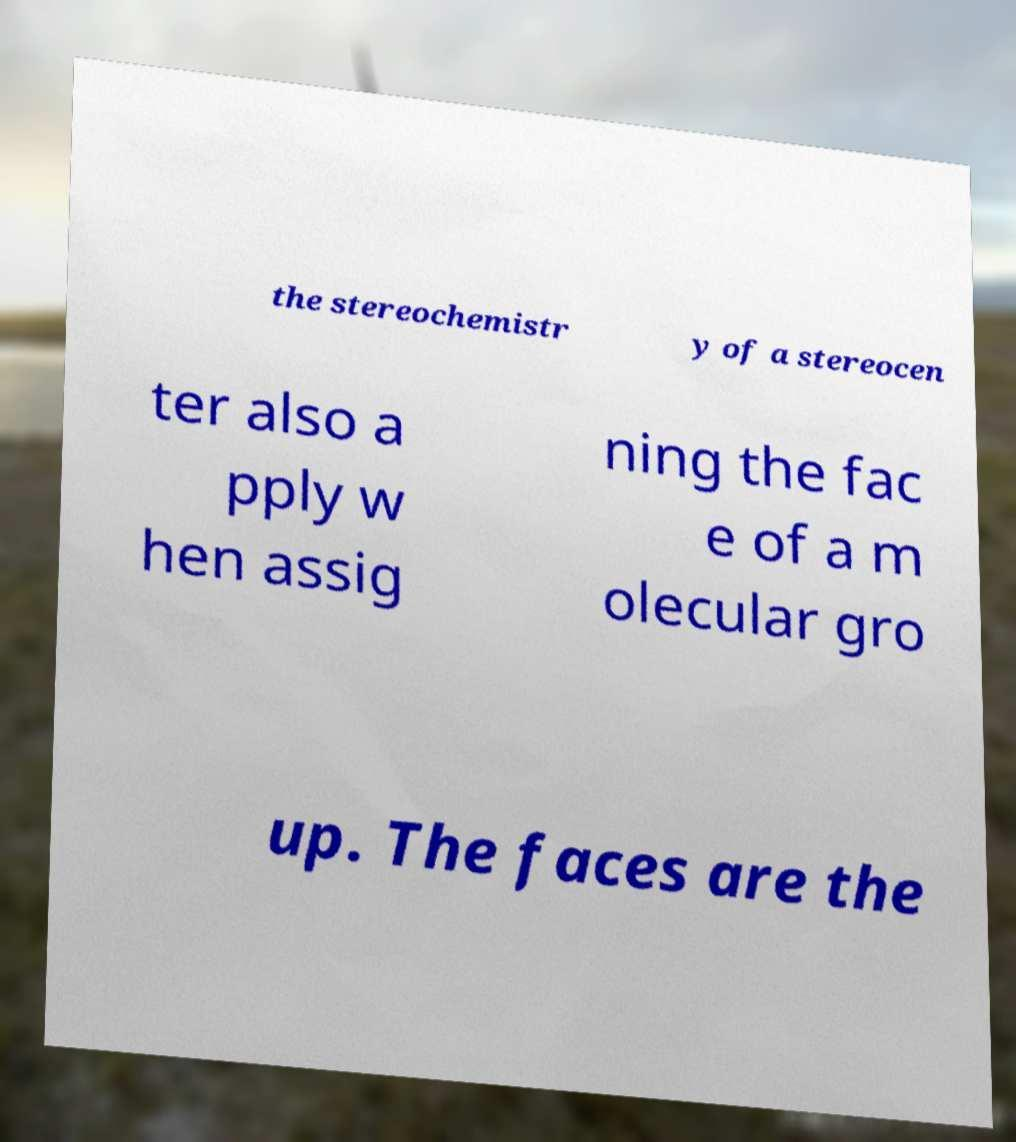Could you assist in decoding the text presented in this image and type it out clearly? the stereochemistr y of a stereocen ter also a pply w hen assig ning the fac e of a m olecular gro up. The faces are the 